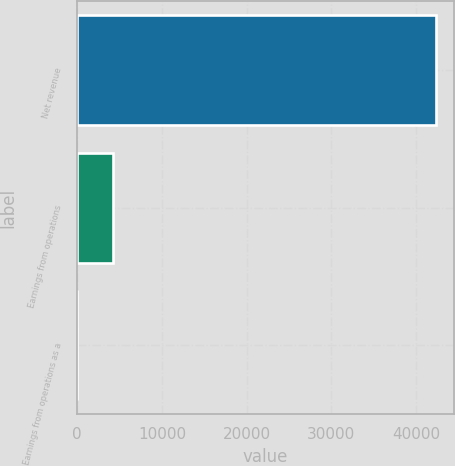Convert chart. <chart><loc_0><loc_0><loc_500><loc_500><bar_chart><fcel>Net revenue<fcel>Earnings from operations<fcel>Earnings from operations as a<nl><fcel>42295<fcel>4234.54<fcel>5.6<nl></chart> 